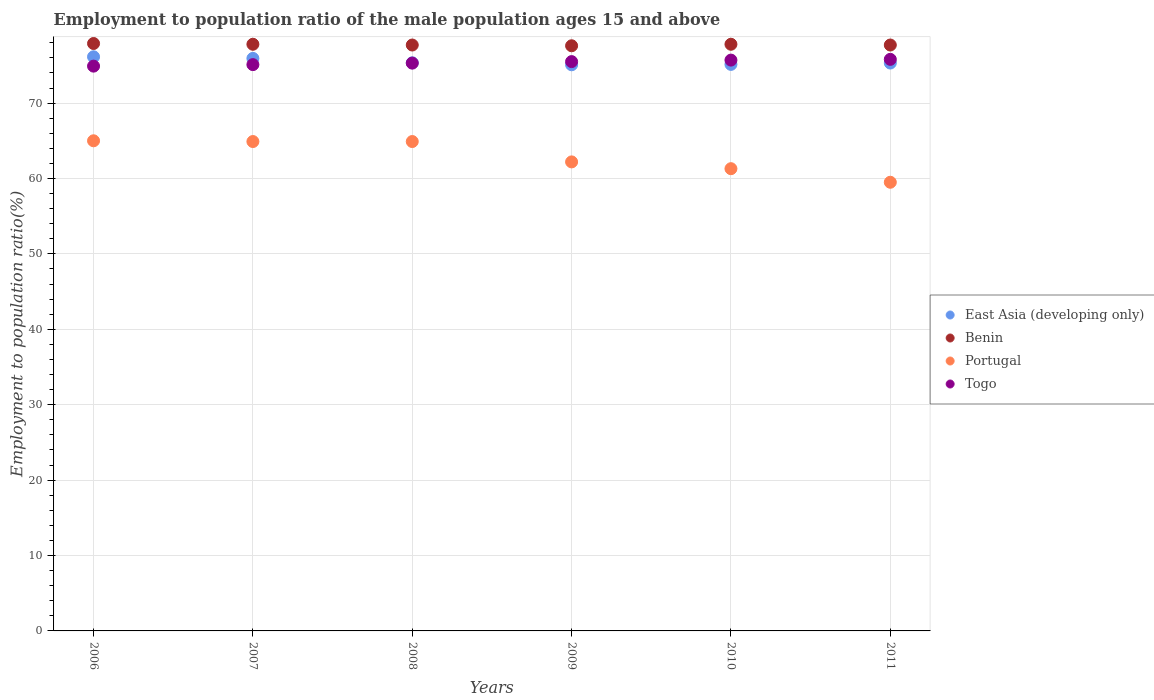What is the employment to population ratio in Benin in 2010?
Offer a very short reply. 77.8. Across all years, what is the maximum employment to population ratio in Benin?
Your answer should be very brief. 77.9. Across all years, what is the minimum employment to population ratio in Portugal?
Offer a very short reply. 59.5. In which year was the employment to population ratio in East Asia (developing only) minimum?
Ensure brevity in your answer.  2009. What is the total employment to population ratio in East Asia (developing only) in the graph?
Offer a very short reply. 452.93. What is the difference between the employment to population ratio in Portugal in 2008 and that in 2011?
Ensure brevity in your answer.  5.4. What is the difference between the employment to population ratio in Benin in 2010 and the employment to population ratio in Portugal in 2007?
Offer a terse response. 12.9. What is the average employment to population ratio in Portugal per year?
Make the answer very short. 62.97. In the year 2007, what is the difference between the employment to population ratio in Togo and employment to population ratio in East Asia (developing only)?
Give a very brief answer. -0.83. In how many years, is the employment to population ratio in Benin greater than 52 %?
Your response must be concise. 6. What is the ratio of the employment to population ratio in Portugal in 2006 to that in 2007?
Offer a very short reply. 1. Is the difference between the employment to population ratio in Togo in 2007 and 2011 greater than the difference between the employment to population ratio in East Asia (developing only) in 2007 and 2011?
Give a very brief answer. No. What is the difference between the highest and the second highest employment to population ratio in Togo?
Your answer should be very brief. 0.1. What is the difference between the highest and the lowest employment to population ratio in Togo?
Ensure brevity in your answer.  0.9. Is it the case that in every year, the sum of the employment to population ratio in Portugal and employment to population ratio in Benin  is greater than the employment to population ratio in East Asia (developing only)?
Give a very brief answer. Yes. Is the employment to population ratio in East Asia (developing only) strictly greater than the employment to population ratio in Benin over the years?
Offer a terse response. No. Is the employment to population ratio in Benin strictly less than the employment to population ratio in East Asia (developing only) over the years?
Provide a short and direct response. No. How many dotlines are there?
Your answer should be very brief. 4. Are the values on the major ticks of Y-axis written in scientific E-notation?
Make the answer very short. No. Does the graph contain any zero values?
Ensure brevity in your answer.  No. Where does the legend appear in the graph?
Give a very brief answer. Center right. How many legend labels are there?
Provide a short and direct response. 4. How are the legend labels stacked?
Your answer should be very brief. Vertical. What is the title of the graph?
Your answer should be compact. Employment to population ratio of the male population ages 15 and above. What is the label or title of the Y-axis?
Offer a terse response. Employment to population ratio(%). What is the Employment to population ratio(%) in East Asia (developing only) in 2006?
Your response must be concise. 76.14. What is the Employment to population ratio(%) of Benin in 2006?
Your answer should be compact. 77.9. What is the Employment to population ratio(%) in Togo in 2006?
Your answer should be very brief. 74.9. What is the Employment to population ratio(%) of East Asia (developing only) in 2007?
Provide a succinct answer. 75.93. What is the Employment to population ratio(%) in Benin in 2007?
Make the answer very short. 77.8. What is the Employment to population ratio(%) in Portugal in 2007?
Make the answer very short. 64.9. What is the Employment to population ratio(%) of Togo in 2007?
Offer a very short reply. 75.1. What is the Employment to population ratio(%) of East Asia (developing only) in 2008?
Make the answer very short. 75.34. What is the Employment to population ratio(%) in Benin in 2008?
Offer a terse response. 77.7. What is the Employment to population ratio(%) in Portugal in 2008?
Ensure brevity in your answer.  64.9. What is the Employment to population ratio(%) of Togo in 2008?
Give a very brief answer. 75.3. What is the Employment to population ratio(%) of East Asia (developing only) in 2009?
Your answer should be very brief. 75.08. What is the Employment to population ratio(%) in Benin in 2009?
Provide a succinct answer. 77.6. What is the Employment to population ratio(%) in Portugal in 2009?
Your answer should be compact. 62.2. What is the Employment to population ratio(%) in Togo in 2009?
Offer a terse response. 75.5. What is the Employment to population ratio(%) of East Asia (developing only) in 2010?
Offer a very short reply. 75.13. What is the Employment to population ratio(%) of Benin in 2010?
Ensure brevity in your answer.  77.8. What is the Employment to population ratio(%) of Portugal in 2010?
Make the answer very short. 61.3. What is the Employment to population ratio(%) of Togo in 2010?
Ensure brevity in your answer.  75.7. What is the Employment to population ratio(%) of East Asia (developing only) in 2011?
Your answer should be compact. 75.31. What is the Employment to population ratio(%) in Benin in 2011?
Give a very brief answer. 77.7. What is the Employment to population ratio(%) in Portugal in 2011?
Your answer should be compact. 59.5. What is the Employment to population ratio(%) of Togo in 2011?
Your response must be concise. 75.8. Across all years, what is the maximum Employment to population ratio(%) of East Asia (developing only)?
Keep it short and to the point. 76.14. Across all years, what is the maximum Employment to population ratio(%) in Benin?
Your answer should be compact. 77.9. Across all years, what is the maximum Employment to population ratio(%) in Portugal?
Offer a terse response. 65. Across all years, what is the maximum Employment to population ratio(%) of Togo?
Your answer should be compact. 75.8. Across all years, what is the minimum Employment to population ratio(%) in East Asia (developing only)?
Make the answer very short. 75.08. Across all years, what is the minimum Employment to population ratio(%) in Benin?
Make the answer very short. 77.6. Across all years, what is the minimum Employment to population ratio(%) of Portugal?
Your answer should be compact. 59.5. Across all years, what is the minimum Employment to population ratio(%) of Togo?
Make the answer very short. 74.9. What is the total Employment to population ratio(%) of East Asia (developing only) in the graph?
Your answer should be compact. 452.93. What is the total Employment to population ratio(%) of Benin in the graph?
Your answer should be compact. 466.5. What is the total Employment to population ratio(%) of Portugal in the graph?
Give a very brief answer. 377.8. What is the total Employment to population ratio(%) in Togo in the graph?
Offer a very short reply. 452.3. What is the difference between the Employment to population ratio(%) of East Asia (developing only) in 2006 and that in 2007?
Your response must be concise. 0.21. What is the difference between the Employment to population ratio(%) in Benin in 2006 and that in 2007?
Provide a succinct answer. 0.1. What is the difference between the Employment to population ratio(%) in East Asia (developing only) in 2006 and that in 2008?
Provide a short and direct response. 0.8. What is the difference between the Employment to population ratio(%) in Benin in 2006 and that in 2008?
Your response must be concise. 0.2. What is the difference between the Employment to population ratio(%) of Portugal in 2006 and that in 2008?
Make the answer very short. 0.1. What is the difference between the Employment to population ratio(%) of Togo in 2006 and that in 2008?
Your answer should be compact. -0.4. What is the difference between the Employment to population ratio(%) in East Asia (developing only) in 2006 and that in 2009?
Offer a very short reply. 1.06. What is the difference between the Employment to population ratio(%) of Benin in 2006 and that in 2009?
Your response must be concise. 0.3. What is the difference between the Employment to population ratio(%) of Portugal in 2006 and that in 2009?
Your response must be concise. 2.8. What is the difference between the Employment to population ratio(%) of East Asia (developing only) in 2006 and that in 2010?
Provide a short and direct response. 1.01. What is the difference between the Employment to population ratio(%) of Portugal in 2006 and that in 2010?
Provide a succinct answer. 3.7. What is the difference between the Employment to population ratio(%) in East Asia (developing only) in 2006 and that in 2011?
Offer a very short reply. 0.83. What is the difference between the Employment to population ratio(%) in Portugal in 2006 and that in 2011?
Ensure brevity in your answer.  5.5. What is the difference between the Employment to population ratio(%) in Togo in 2006 and that in 2011?
Ensure brevity in your answer.  -0.9. What is the difference between the Employment to population ratio(%) of East Asia (developing only) in 2007 and that in 2008?
Ensure brevity in your answer.  0.59. What is the difference between the Employment to population ratio(%) in Togo in 2007 and that in 2008?
Offer a terse response. -0.2. What is the difference between the Employment to population ratio(%) of East Asia (developing only) in 2007 and that in 2009?
Ensure brevity in your answer.  0.85. What is the difference between the Employment to population ratio(%) of Portugal in 2007 and that in 2009?
Ensure brevity in your answer.  2.7. What is the difference between the Employment to population ratio(%) in Togo in 2007 and that in 2009?
Ensure brevity in your answer.  -0.4. What is the difference between the Employment to population ratio(%) of East Asia (developing only) in 2007 and that in 2010?
Provide a succinct answer. 0.8. What is the difference between the Employment to population ratio(%) of East Asia (developing only) in 2007 and that in 2011?
Offer a terse response. 0.62. What is the difference between the Employment to population ratio(%) of Portugal in 2007 and that in 2011?
Give a very brief answer. 5.4. What is the difference between the Employment to population ratio(%) of East Asia (developing only) in 2008 and that in 2009?
Provide a succinct answer. 0.26. What is the difference between the Employment to population ratio(%) in Benin in 2008 and that in 2009?
Your answer should be very brief. 0.1. What is the difference between the Employment to population ratio(%) of Portugal in 2008 and that in 2009?
Ensure brevity in your answer.  2.7. What is the difference between the Employment to population ratio(%) in Togo in 2008 and that in 2009?
Offer a very short reply. -0.2. What is the difference between the Employment to population ratio(%) of East Asia (developing only) in 2008 and that in 2010?
Give a very brief answer. 0.21. What is the difference between the Employment to population ratio(%) in Togo in 2008 and that in 2010?
Provide a succinct answer. -0.4. What is the difference between the Employment to population ratio(%) in East Asia (developing only) in 2008 and that in 2011?
Your response must be concise. 0.03. What is the difference between the Employment to population ratio(%) in Portugal in 2008 and that in 2011?
Give a very brief answer. 5.4. What is the difference between the Employment to population ratio(%) of East Asia (developing only) in 2009 and that in 2010?
Your response must be concise. -0.05. What is the difference between the Employment to population ratio(%) in Benin in 2009 and that in 2010?
Offer a terse response. -0.2. What is the difference between the Employment to population ratio(%) of Portugal in 2009 and that in 2010?
Ensure brevity in your answer.  0.9. What is the difference between the Employment to population ratio(%) of Togo in 2009 and that in 2010?
Your answer should be compact. -0.2. What is the difference between the Employment to population ratio(%) in East Asia (developing only) in 2009 and that in 2011?
Provide a succinct answer. -0.23. What is the difference between the Employment to population ratio(%) in Togo in 2009 and that in 2011?
Provide a short and direct response. -0.3. What is the difference between the Employment to population ratio(%) in East Asia (developing only) in 2010 and that in 2011?
Provide a succinct answer. -0.18. What is the difference between the Employment to population ratio(%) in Benin in 2010 and that in 2011?
Provide a succinct answer. 0.1. What is the difference between the Employment to population ratio(%) in Portugal in 2010 and that in 2011?
Keep it short and to the point. 1.8. What is the difference between the Employment to population ratio(%) of East Asia (developing only) in 2006 and the Employment to population ratio(%) of Benin in 2007?
Provide a succinct answer. -1.66. What is the difference between the Employment to population ratio(%) in East Asia (developing only) in 2006 and the Employment to population ratio(%) in Portugal in 2007?
Give a very brief answer. 11.24. What is the difference between the Employment to population ratio(%) of East Asia (developing only) in 2006 and the Employment to population ratio(%) of Togo in 2007?
Offer a very short reply. 1.04. What is the difference between the Employment to population ratio(%) of Benin in 2006 and the Employment to population ratio(%) of Portugal in 2007?
Your response must be concise. 13. What is the difference between the Employment to population ratio(%) in Portugal in 2006 and the Employment to population ratio(%) in Togo in 2007?
Provide a short and direct response. -10.1. What is the difference between the Employment to population ratio(%) of East Asia (developing only) in 2006 and the Employment to population ratio(%) of Benin in 2008?
Your answer should be very brief. -1.56. What is the difference between the Employment to population ratio(%) of East Asia (developing only) in 2006 and the Employment to population ratio(%) of Portugal in 2008?
Provide a succinct answer. 11.24. What is the difference between the Employment to population ratio(%) in East Asia (developing only) in 2006 and the Employment to population ratio(%) in Togo in 2008?
Your response must be concise. 0.84. What is the difference between the Employment to population ratio(%) in Benin in 2006 and the Employment to population ratio(%) in Portugal in 2008?
Offer a terse response. 13. What is the difference between the Employment to population ratio(%) of Benin in 2006 and the Employment to population ratio(%) of Togo in 2008?
Provide a succinct answer. 2.6. What is the difference between the Employment to population ratio(%) of East Asia (developing only) in 2006 and the Employment to population ratio(%) of Benin in 2009?
Give a very brief answer. -1.46. What is the difference between the Employment to population ratio(%) in East Asia (developing only) in 2006 and the Employment to population ratio(%) in Portugal in 2009?
Keep it short and to the point. 13.94. What is the difference between the Employment to population ratio(%) of East Asia (developing only) in 2006 and the Employment to population ratio(%) of Togo in 2009?
Ensure brevity in your answer.  0.64. What is the difference between the Employment to population ratio(%) in East Asia (developing only) in 2006 and the Employment to population ratio(%) in Benin in 2010?
Keep it short and to the point. -1.66. What is the difference between the Employment to population ratio(%) of East Asia (developing only) in 2006 and the Employment to population ratio(%) of Portugal in 2010?
Your answer should be compact. 14.84. What is the difference between the Employment to population ratio(%) in East Asia (developing only) in 2006 and the Employment to population ratio(%) in Togo in 2010?
Your response must be concise. 0.44. What is the difference between the Employment to population ratio(%) in Benin in 2006 and the Employment to population ratio(%) in Portugal in 2010?
Provide a succinct answer. 16.6. What is the difference between the Employment to population ratio(%) of East Asia (developing only) in 2006 and the Employment to population ratio(%) of Benin in 2011?
Your answer should be very brief. -1.56. What is the difference between the Employment to population ratio(%) of East Asia (developing only) in 2006 and the Employment to population ratio(%) of Portugal in 2011?
Offer a very short reply. 16.64. What is the difference between the Employment to population ratio(%) of East Asia (developing only) in 2006 and the Employment to population ratio(%) of Togo in 2011?
Your answer should be compact. 0.34. What is the difference between the Employment to population ratio(%) in Benin in 2006 and the Employment to population ratio(%) in Togo in 2011?
Keep it short and to the point. 2.1. What is the difference between the Employment to population ratio(%) of Portugal in 2006 and the Employment to population ratio(%) of Togo in 2011?
Your response must be concise. -10.8. What is the difference between the Employment to population ratio(%) in East Asia (developing only) in 2007 and the Employment to population ratio(%) in Benin in 2008?
Provide a succinct answer. -1.77. What is the difference between the Employment to population ratio(%) in East Asia (developing only) in 2007 and the Employment to population ratio(%) in Portugal in 2008?
Give a very brief answer. 11.03. What is the difference between the Employment to population ratio(%) of East Asia (developing only) in 2007 and the Employment to population ratio(%) of Togo in 2008?
Your answer should be compact. 0.63. What is the difference between the Employment to population ratio(%) in Benin in 2007 and the Employment to population ratio(%) in Portugal in 2008?
Your answer should be very brief. 12.9. What is the difference between the Employment to population ratio(%) in Benin in 2007 and the Employment to population ratio(%) in Togo in 2008?
Provide a short and direct response. 2.5. What is the difference between the Employment to population ratio(%) in Portugal in 2007 and the Employment to population ratio(%) in Togo in 2008?
Offer a very short reply. -10.4. What is the difference between the Employment to population ratio(%) of East Asia (developing only) in 2007 and the Employment to population ratio(%) of Benin in 2009?
Give a very brief answer. -1.67. What is the difference between the Employment to population ratio(%) of East Asia (developing only) in 2007 and the Employment to population ratio(%) of Portugal in 2009?
Offer a terse response. 13.73. What is the difference between the Employment to population ratio(%) in East Asia (developing only) in 2007 and the Employment to population ratio(%) in Togo in 2009?
Make the answer very short. 0.43. What is the difference between the Employment to population ratio(%) of Benin in 2007 and the Employment to population ratio(%) of Portugal in 2009?
Your answer should be compact. 15.6. What is the difference between the Employment to population ratio(%) of Benin in 2007 and the Employment to population ratio(%) of Togo in 2009?
Ensure brevity in your answer.  2.3. What is the difference between the Employment to population ratio(%) in Portugal in 2007 and the Employment to population ratio(%) in Togo in 2009?
Ensure brevity in your answer.  -10.6. What is the difference between the Employment to population ratio(%) in East Asia (developing only) in 2007 and the Employment to population ratio(%) in Benin in 2010?
Your answer should be very brief. -1.87. What is the difference between the Employment to population ratio(%) of East Asia (developing only) in 2007 and the Employment to population ratio(%) of Portugal in 2010?
Your answer should be compact. 14.63. What is the difference between the Employment to population ratio(%) in East Asia (developing only) in 2007 and the Employment to population ratio(%) in Togo in 2010?
Offer a very short reply. 0.23. What is the difference between the Employment to population ratio(%) of Benin in 2007 and the Employment to population ratio(%) of Portugal in 2010?
Your answer should be very brief. 16.5. What is the difference between the Employment to population ratio(%) of Benin in 2007 and the Employment to population ratio(%) of Togo in 2010?
Your answer should be compact. 2.1. What is the difference between the Employment to population ratio(%) of Portugal in 2007 and the Employment to population ratio(%) of Togo in 2010?
Offer a terse response. -10.8. What is the difference between the Employment to population ratio(%) in East Asia (developing only) in 2007 and the Employment to population ratio(%) in Benin in 2011?
Give a very brief answer. -1.77. What is the difference between the Employment to population ratio(%) of East Asia (developing only) in 2007 and the Employment to population ratio(%) of Portugal in 2011?
Your response must be concise. 16.43. What is the difference between the Employment to population ratio(%) in East Asia (developing only) in 2007 and the Employment to population ratio(%) in Togo in 2011?
Ensure brevity in your answer.  0.13. What is the difference between the Employment to population ratio(%) in Benin in 2007 and the Employment to population ratio(%) in Portugal in 2011?
Offer a terse response. 18.3. What is the difference between the Employment to population ratio(%) in Portugal in 2007 and the Employment to population ratio(%) in Togo in 2011?
Provide a succinct answer. -10.9. What is the difference between the Employment to population ratio(%) of East Asia (developing only) in 2008 and the Employment to population ratio(%) of Benin in 2009?
Keep it short and to the point. -2.26. What is the difference between the Employment to population ratio(%) of East Asia (developing only) in 2008 and the Employment to population ratio(%) of Portugal in 2009?
Your response must be concise. 13.14. What is the difference between the Employment to population ratio(%) in East Asia (developing only) in 2008 and the Employment to population ratio(%) in Togo in 2009?
Offer a terse response. -0.16. What is the difference between the Employment to population ratio(%) of Benin in 2008 and the Employment to population ratio(%) of Portugal in 2009?
Your answer should be compact. 15.5. What is the difference between the Employment to population ratio(%) of Portugal in 2008 and the Employment to population ratio(%) of Togo in 2009?
Your answer should be compact. -10.6. What is the difference between the Employment to population ratio(%) in East Asia (developing only) in 2008 and the Employment to population ratio(%) in Benin in 2010?
Offer a very short reply. -2.46. What is the difference between the Employment to population ratio(%) in East Asia (developing only) in 2008 and the Employment to population ratio(%) in Portugal in 2010?
Give a very brief answer. 14.04. What is the difference between the Employment to population ratio(%) of East Asia (developing only) in 2008 and the Employment to population ratio(%) of Togo in 2010?
Your answer should be compact. -0.36. What is the difference between the Employment to population ratio(%) of Benin in 2008 and the Employment to population ratio(%) of Portugal in 2010?
Your answer should be compact. 16.4. What is the difference between the Employment to population ratio(%) of Benin in 2008 and the Employment to population ratio(%) of Togo in 2010?
Your response must be concise. 2. What is the difference between the Employment to population ratio(%) in Portugal in 2008 and the Employment to population ratio(%) in Togo in 2010?
Provide a succinct answer. -10.8. What is the difference between the Employment to population ratio(%) in East Asia (developing only) in 2008 and the Employment to population ratio(%) in Benin in 2011?
Offer a terse response. -2.36. What is the difference between the Employment to population ratio(%) in East Asia (developing only) in 2008 and the Employment to population ratio(%) in Portugal in 2011?
Offer a very short reply. 15.84. What is the difference between the Employment to population ratio(%) in East Asia (developing only) in 2008 and the Employment to population ratio(%) in Togo in 2011?
Keep it short and to the point. -0.46. What is the difference between the Employment to population ratio(%) of Benin in 2008 and the Employment to population ratio(%) of Portugal in 2011?
Make the answer very short. 18.2. What is the difference between the Employment to population ratio(%) in East Asia (developing only) in 2009 and the Employment to population ratio(%) in Benin in 2010?
Your response must be concise. -2.72. What is the difference between the Employment to population ratio(%) of East Asia (developing only) in 2009 and the Employment to population ratio(%) of Portugal in 2010?
Give a very brief answer. 13.78. What is the difference between the Employment to population ratio(%) in East Asia (developing only) in 2009 and the Employment to population ratio(%) in Togo in 2010?
Offer a terse response. -0.62. What is the difference between the Employment to population ratio(%) of Benin in 2009 and the Employment to population ratio(%) of Portugal in 2010?
Offer a very short reply. 16.3. What is the difference between the Employment to population ratio(%) in Portugal in 2009 and the Employment to population ratio(%) in Togo in 2010?
Make the answer very short. -13.5. What is the difference between the Employment to population ratio(%) in East Asia (developing only) in 2009 and the Employment to population ratio(%) in Benin in 2011?
Provide a short and direct response. -2.62. What is the difference between the Employment to population ratio(%) in East Asia (developing only) in 2009 and the Employment to population ratio(%) in Portugal in 2011?
Offer a very short reply. 15.58. What is the difference between the Employment to population ratio(%) in East Asia (developing only) in 2009 and the Employment to population ratio(%) in Togo in 2011?
Your response must be concise. -0.72. What is the difference between the Employment to population ratio(%) in East Asia (developing only) in 2010 and the Employment to population ratio(%) in Benin in 2011?
Give a very brief answer. -2.57. What is the difference between the Employment to population ratio(%) of East Asia (developing only) in 2010 and the Employment to population ratio(%) of Portugal in 2011?
Offer a very short reply. 15.63. What is the difference between the Employment to population ratio(%) in East Asia (developing only) in 2010 and the Employment to population ratio(%) in Togo in 2011?
Provide a succinct answer. -0.67. What is the difference between the Employment to population ratio(%) of Benin in 2010 and the Employment to population ratio(%) of Portugal in 2011?
Make the answer very short. 18.3. What is the difference between the Employment to population ratio(%) in Portugal in 2010 and the Employment to population ratio(%) in Togo in 2011?
Make the answer very short. -14.5. What is the average Employment to population ratio(%) in East Asia (developing only) per year?
Make the answer very short. 75.49. What is the average Employment to population ratio(%) in Benin per year?
Make the answer very short. 77.75. What is the average Employment to population ratio(%) in Portugal per year?
Ensure brevity in your answer.  62.97. What is the average Employment to population ratio(%) of Togo per year?
Your response must be concise. 75.38. In the year 2006, what is the difference between the Employment to population ratio(%) of East Asia (developing only) and Employment to population ratio(%) of Benin?
Make the answer very short. -1.76. In the year 2006, what is the difference between the Employment to population ratio(%) in East Asia (developing only) and Employment to population ratio(%) in Portugal?
Offer a very short reply. 11.14. In the year 2006, what is the difference between the Employment to population ratio(%) of East Asia (developing only) and Employment to population ratio(%) of Togo?
Provide a short and direct response. 1.24. In the year 2007, what is the difference between the Employment to population ratio(%) in East Asia (developing only) and Employment to population ratio(%) in Benin?
Make the answer very short. -1.87. In the year 2007, what is the difference between the Employment to population ratio(%) of East Asia (developing only) and Employment to population ratio(%) of Portugal?
Offer a terse response. 11.03. In the year 2007, what is the difference between the Employment to population ratio(%) of East Asia (developing only) and Employment to population ratio(%) of Togo?
Provide a succinct answer. 0.83. In the year 2007, what is the difference between the Employment to population ratio(%) of Benin and Employment to population ratio(%) of Portugal?
Ensure brevity in your answer.  12.9. In the year 2008, what is the difference between the Employment to population ratio(%) in East Asia (developing only) and Employment to population ratio(%) in Benin?
Offer a very short reply. -2.36. In the year 2008, what is the difference between the Employment to population ratio(%) of East Asia (developing only) and Employment to population ratio(%) of Portugal?
Give a very brief answer. 10.44. In the year 2008, what is the difference between the Employment to population ratio(%) in East Asia (developing only) and Employment to population ratio(%) in Togo?
Ensure brevity in your answer.  0.04. In the year 2008, what is the difference between the Employment to population ratio(%) in Benin and Employment to population ratio(%) in Portugal?
Your response must be concise. 12.8. In the year 2009, what is the difference between the Employment to population ratio(%) in East Asia (developing only) and Employment to population ratio(%) in Benin?
Provide a succinct answer. -2.52. In the year 2009, what is the difference between the Employment to population ratio(%) of East Asia (developing only) and Employment to population ratio(%) of Portugal?
Give a very brief answer. 12.88. In the year 2009, what is the difference between the Employment to population ratio(%) in East Asia (developing only) and Employment to population ratio(%) in Togo?
Keep it short and to the point. -0.42. In the year 2009, what is the difference between the Employment to population ratio(%) in Benin and Employment to population ratio(%) in Portugal?
Offer a very short reply. 15.4. In the year 2009, what is the difference between the Employment to population ratio(%) of Benin and Employment to population ratio(%) of Togo?
Provide a short and direct response. 2.1. In the year 2010, what is the difference between the Employment to population ratio(%) in East Asia (developing only) and Employment to population ratio(%) in Benin?
Offer a terse response. -2.67. In the year 2010, what is the difference between the Employment to population ratio(%) of East Asia (developing only) and Employment to population ratio(%) of Portugal?
Give a very brief answer. 13.83. In the year 2010, what is the difference between the Employment to population ratio(%) of East Asia (developing only) and Employment to population ratio(%) of Togo?
Your answer should be compact. -0.57. In the year 2010, what is the difference between the Employment to population ratio(%) in Benin and Employment to population ratio(%) in Portugal?
Your answer should be very brief. 16.5. In the year 2010, what is the difference between the Employment to population ratio(%) of Benin and Employment to population ratio(%) of Togo?
Keep it short and to the point. 2.1. In the year 2010, what is the difference between the Employment to population ratio(%) in Portugal and Employment to population ratio(%) in Togo?
Make the answer very short. -14.4. In the year 2011, what is the difference between the Employment to population ratio(%) of East Asia (developing only) and Employment to population ratio(%) of Benin?
Provide a short and direct response. -2.39. In the year 2011, what is the difference between the Employment to population ratio(%) of East Asia (developing only) and Employment to population ratio(%) of Portugal?
Offer a terse response. 15.81. In the year 2011, what is the difference between the Employment to population ratio(%) in East Asia (developing only) and Employment to population ratio(%) in Togo?
Give a very brief answer. -0.49. In the year 2011, what is the difference between the Employment to population ratio(%) in Portugal and Employment to population ratio(%) in Togo?
Your answer should be very brief. -16.3. What is the ratio of the Employment to population ratio(%) in Togo in 2006 to that in 2007?
Your answer should be compact. 1. What is the ratio of the Employment to population ratio(%) of East Asia (developing only) in 2006 to that in 2008?
Your answer should be very brief. 1.01. What is the ratio of the Employment to population ratio(%) in East Asia (developing only) in 2006 to that in 2009?
Keep it short and to the point. 1.01. What is the ratio of the Employment to population ratio(%) in Benin in 2006 to that in 2009?
Your response must be concise. 1. What is the ratio of the Employment to population ratio(%) of Portugal in 2006 to that in 2009?
Give a very brief answer. 1.04. What is the ratio of the Employment to population ratio(%) in East Asia (developing only) in 2006 to that in 2010?
Offer a very short reply. 1.01. What is the ratio of the Employment to population ratio(%) in Benin in 2006 to that in 2010?
Ensure brevity in your answer.  1. What is the ratio of the Employment to population ratio(%) of Portugal in 2006 to that in 2010?
Your answer should be very brief. 1.06. What is the ratio of the Employment to population ratio(%) in Togo in 2006 to that in 2010?
Ensure brevity in your answer.  0.99. What is the ratio of the Employment to population ratio(%) in Portugal in 2006 to that in 2011?
Your response must be concise. 1.09. What is the ratio of the Employment to population ratio(%) of Togo in 2006 to that in 2011?
Provide a short and direct response. 0.99. What is the ratio of the Employment to population ratio(%) of Benin in 2007 to that in 2008?
Keep it short and to the point. 1. What is the ratio of the Employment to population ratio(%) in Portugal in 2007 to that in 2008?
Provide a short and direct response. 1. What is the ratio of the Employment to population ratio(%) in Togo in 2007 to that in 2008?
Give a very brief answer. 1. What is the ratio of the Employment to population ratio(%) of East Asia (developing only) in 2007 to that in 2009?
Provide a short and direct response. 1.01. What is the ratio of the Employment to population ratio(%) in Benin in 2007 to that in 2009?
Make the answer very short. 1. What is the ratio of the Employment to population ratio(%) in Portugal in 2007 to that in 2009?
Your answer should be very brief. 1.04. What is the ratio of the Employment to population ratio(%) in East Asia (developing only) in 2007 to that in 2010?
Make the answer very short. 1.01. What is the ratio of the Employment to population ratio(%) in Benin in 2007 to that in 2010?
Offer a terse response. 1. What is the ratio of the Employment to population ratio(%) in Portugal in 2007 to that in 2010?
Give a very brief answer. 1.06. What is the ratio of the Employment to population ratio(%) of Togo in 2007 to that in 2010?
Provide a succinct answer. 0.99. What is the ratio of the Employment to population ratio(%) in East Asia (developing only) in 2007 to that in 2011?
Your answer should be very brief. 1.01. What is the ratio of the Employment to population ratio(%) in Benin in 2007 to that in 2011?
Ensure brevity in your answer.  1. What is the ratio of the Employment to population ratio(%) of Portugal in 2007 to that in 2011?
Your answer should be very brief. 1.09. What is the ratio of the Employment to population ratio(%) of Benin in 2008 to that in 2009?
Provide a short and direct response. 1. What is the ratio of the Employment to population ratio(%) in Portugal in 2008 to that in 2009?
Provide a succinct answer. 1.04. What is the ratio of the Employment to population ratio(%) in Benin in 2008 to that in 2010?
Provide a short and direct response. 1. What is the ratio of the Employment to population ratio(%) of Portugal in 2008 to that in 2010?
Your answer should be very brief. 1.06. What is the ratio of the Employment to population ratio(%) of East Asia (developing only) in 2008 to that in 2011?
Give a very brief answer. 1. What is the ratio of the Employment to population ratio(%) of Benin in 2008 to that in 2011?
Your answer should be compact. 1. What is the ratio of the Employment to population ratio(%) in Portugal in 2008 to that in 2011?
Offer a very short reply. 1.09. What is the ratio of the Employment to population ratio(%) of Togo in 2008 to that in 2011?
Provide a short and direct response. 0.99. What is the ratio of the Employment to population ratio(%) in East Asia (developing only) in 2009 to that in 2010?
Provide a short and direct response. 1. What is the ratio of the Employment to population ratio(%) in Benin in 2009 to that in 2010?
Give a very brief answer. 1. What is the ratio of the Employment to population ratio(%) in Portugal in 2009 to that in 2010?
Keep it short and to the point. 1.01. What is the ratio of the Employment to population ratio(%) of Togo in 2009 to that in 2010?
Offer a terse response. 1. What is the ratio of the Employment to population ratio(%) of East Asia (developing only) in 2009 to that in 2011?
Offer a terse response. 1. What is the ratio of the Employment to population ratio(%) of Portugal in 2009 to that in 2011?
Offer a very short reply. 1.05. What is the ratio of the Employment to population ratio(%) in Togo in 2009 to that in 2011?
Your response must be concise. 1. What is the ratio of the Employment to population ratio(%) of Portugal in 2010 to that in 2011?
Ensure brevity in your answer.  1.03. What is the difference between the highest and the second highest Employment to population ratio(%) in East Asia (developing only)?
Keep it short and to the point. 0.21. What is the difference between the highest and the second highest Employment to population ratio(%) of Benin?
Provide a succinct answer. 0.1. What is the difference between the highest and the second highest Employment to population ratio(%) of Togo?
Your response must be concise. 0.1. What is the difference between the highest and the lowest Employment to population ratio(%) in East Asia (developing only)?
Ensure brevity in your answer.  1.06. 